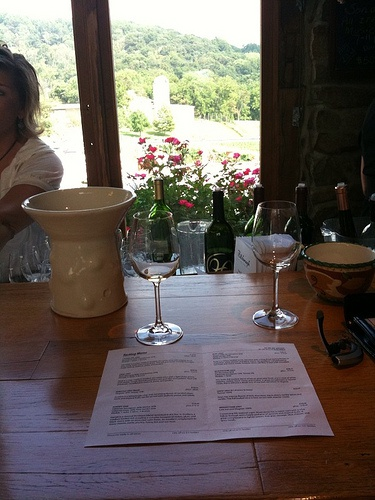Describe the objects in this image and their specific colors. I can see dining table in white, gray, maroon, black, and darkgray tones, people in white, black, and gray tones, vase in white, maroon, gray, and black tones, potted plant in white, ivory, black, and darkgreen tones, and wine glass in white, black, gray, maroon, and darkgray tones in this image. 